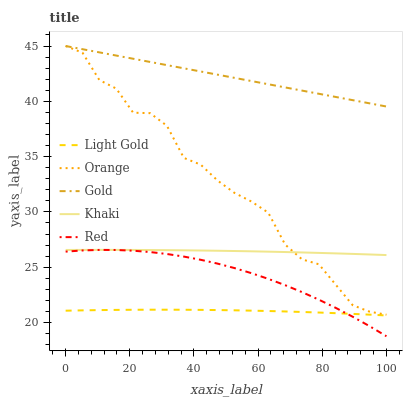Does Light Gold have the minimum area under the curve?
Answer yes or no. Yes. Does Gold have the maximum area under the curve?
Answer yes or no. Yes. Does Khaki have the minimum area under the curve?
Answer yes or no. No. Does Khaki have the maximum area under the curve?
Answer yes or no. No. Is Gold the smoothest?
Answer yes or no. Yes. Is Orange the roughest?
Answer yes or no. Yes. Is Khaki the smoothest?
Answer yes or no. No. Is Khaki the roughest?
Answer yes or no. No. Does Red have the lowest value?
Answer yes or no. Yes. Does Khaki have the lowest value?
Answer yes or no. No. Does Gold have the highest value?
Answer yes or no. Yes. Does Khaki have the highest value?
Answer yes or no. No. Is Khaki less than Gold?
Answer yes or no. Yes. Is Khaki greater than Red?
Answer yes or no. Yes. Does Gold intersect Orange?
Answer yes or no. Yes. Is Gold less than Orange?
Answer yes or no. No. Is Gold greater than Orange?
Answer yes or no. No. Does Khaki intersect Gold?
Answer yes or no. No. 